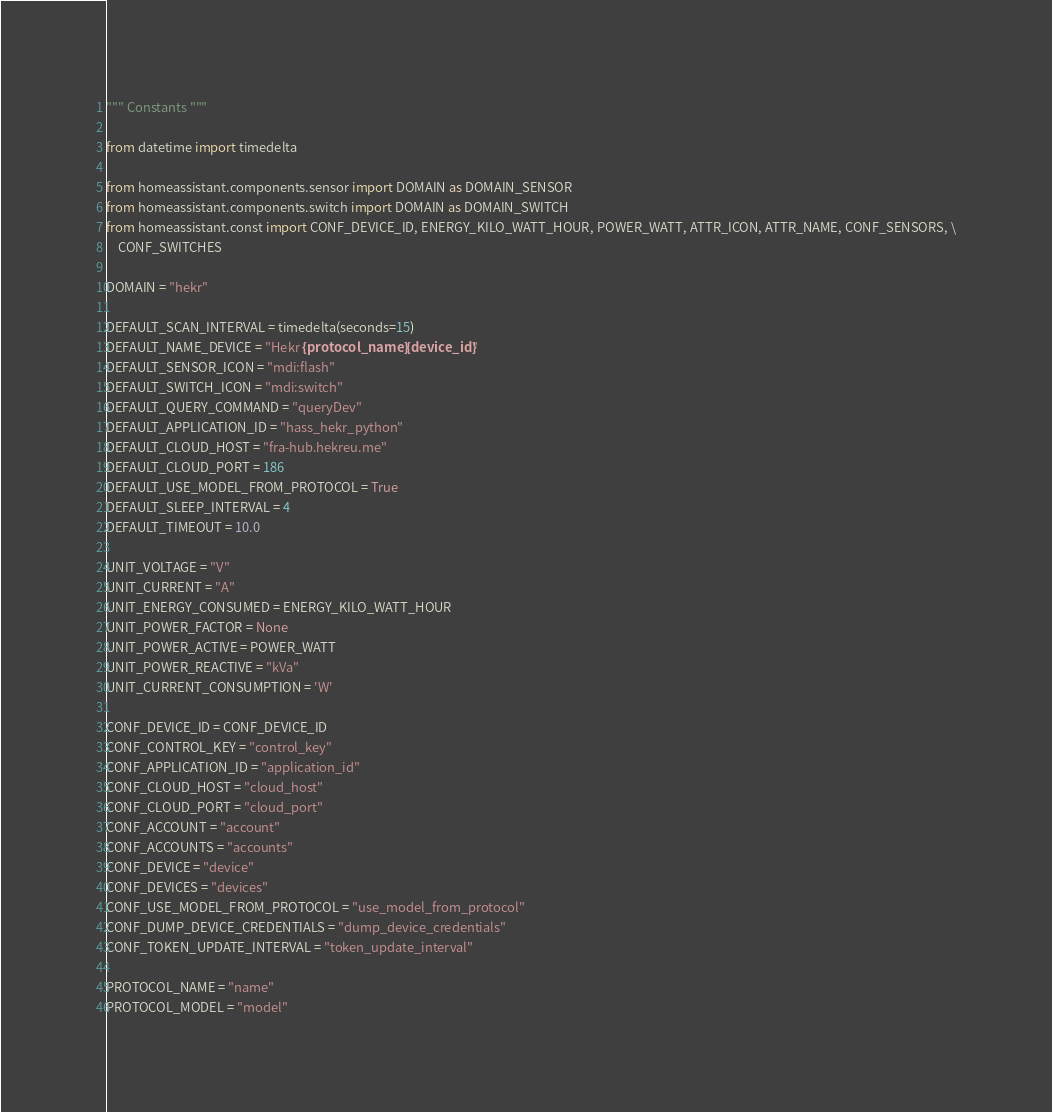Convert code to text. <code><loc_0><loc_0><loc_500><loc_500><_Python_>""" Constants """

from datetime import timedelta

from homeassistant.components.sensor import DOMAIN as DOMAIN_SENSOR
from homeassistant.components.switch import DOMAIN as DOMAIN_SWITCH
from homeassistant.const import CONF_DEVICE_ID, ENERGY_KILO_WATT_HOUR, POWER_WATT, ATTR_ICON, ATTR_NAME, CONF_SENSORS, \
    CONF_SWITCHES

DOMAIN = "hekr"

DEFAULT_SCAN_INTERVAL = timedelta(seconds=15)
DEFAULT_NAME_DEVICE = "Hekr {protocol_name} {device_id}"
DEFAULT_SENSOR_ICON = "mdi:flash"
DEFAULT_SWITCH_ICON = "mdi:switch"
DEFAULT_QUERY_COMMAND = "queryDev"
DEFAULT_APPLICATION_ID = "hass_hekr_python"
DEFAULT_CLOUD_HOST = "fra-hub.hekreu.me"
DEFAULT_CLOUD_PORT = 186
DEFAULT_USE_MODEL_FROM_PROTOCOL = True
DEFAULT_SLEEP_INTERVAL = 4
DEFAULT_TIMEOUT = 10.0

UNIT_VOLTAGE = "V"
UNIT_CURRENT = "A"
UNIT_ENERGY_CONSUMED = ENERGY_KILO_WATT_HOUR
UNIT_POWER_FACTOR = None
UNIT_POWER_ACTIVE = POWER_WATT
UNIT_POWER_REACTIVE = "kVa"
UNIT_CURRENT_CONSUMPTION = 'W'

CONF_DEVICE_ID = CONF_DEVICE_ID
CONF_CONTROL_KEY = "control_key"
CONF_APPLICATION_ID = "application_id"
CONF_CLOUD_HOST = "cloud_host"
CONF_CLOUD_PORT = "cloud_port"
CONF_ACCOUNT = "account"
CONF_ACCOUNTS = "accounts"
CONF_DEVICE = "device"
CONF_DEVICES = "devices"
CONF_USE_MODEL_FROM_PROTOCOL = "use_model_from_protocol"
CONF_DUMP_DEVICE_CREDENTIALS = "dump_device_credentials"
CONF_TOKEN_UPDATE_INTERVAL = "token_update_interval"

PROTOCOL_NAME = "name"
PROTOCOL_MODEL = "model"</code> 